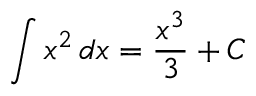Convert formula to latex. <formula><loc_0><loc_0><loc_500><loc_500>\int x ^ { 2 } \, d x = { \frac { x ^ { 3 } } { 3 } } + C</formula> 